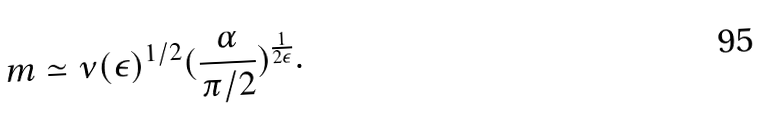<formula> <loc_0><loc_0><loc_500><loc_500>m \simeq \nu ( \epsilon ) ^ { 1 / 2 } ( \frac { \alpha } { \pi / 2 } ) ^ { \frac { 1 } { 2 \epsilon } } .</formula> 